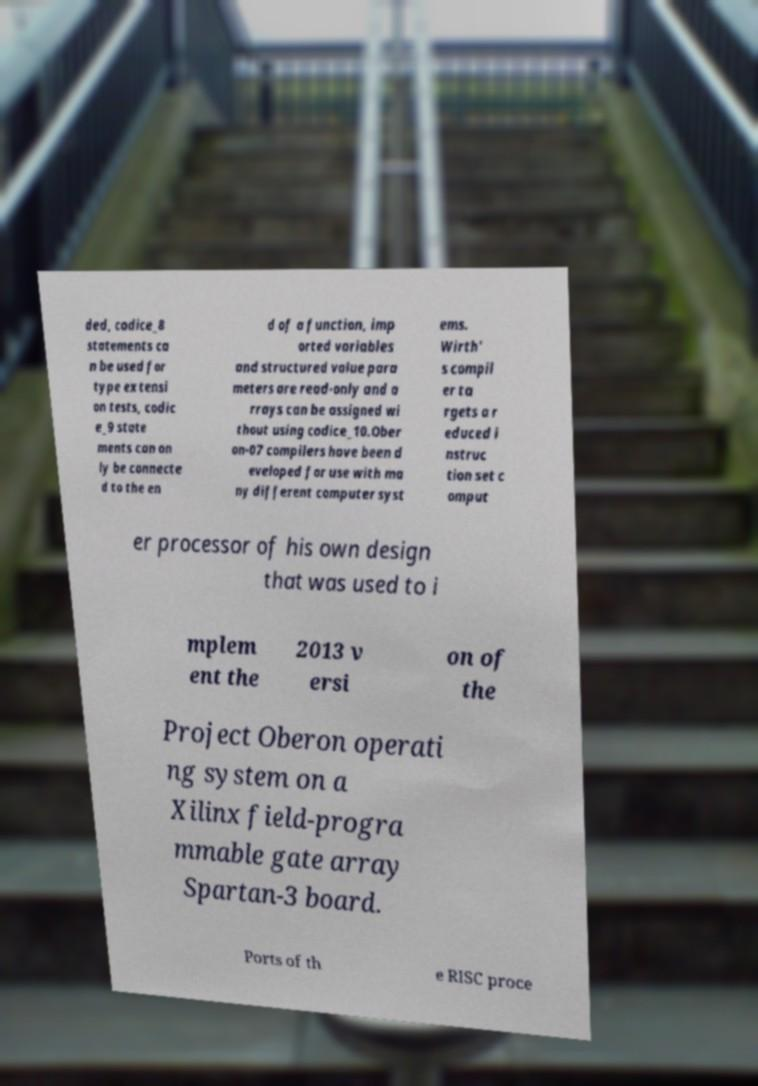Can you read and provide the text displayed in the image?This photo seems to have some interesting text. Can you extract and type it out for me? ded, codice_8 statements ca n be used for type extensi on tests, codic e_9 state ments can on ly be connecte d to the en d of a function, imp orted variables and structured value para meters are read-only and a rrays can be assigned wi thout using codice_10.Ober on-07 compilers have been d eveloped for use with ma ny different computer syst ems. Wirth' s compil er ta rgets a r educed i nstruc tion set c omput er processor of his own design that was used to i mplem ent the 2013 v ersi on of the Project Oberon operati ng system on a Xilinx field-progra mmable gate array Spartan-3 board. Ports of th e RISC proce 